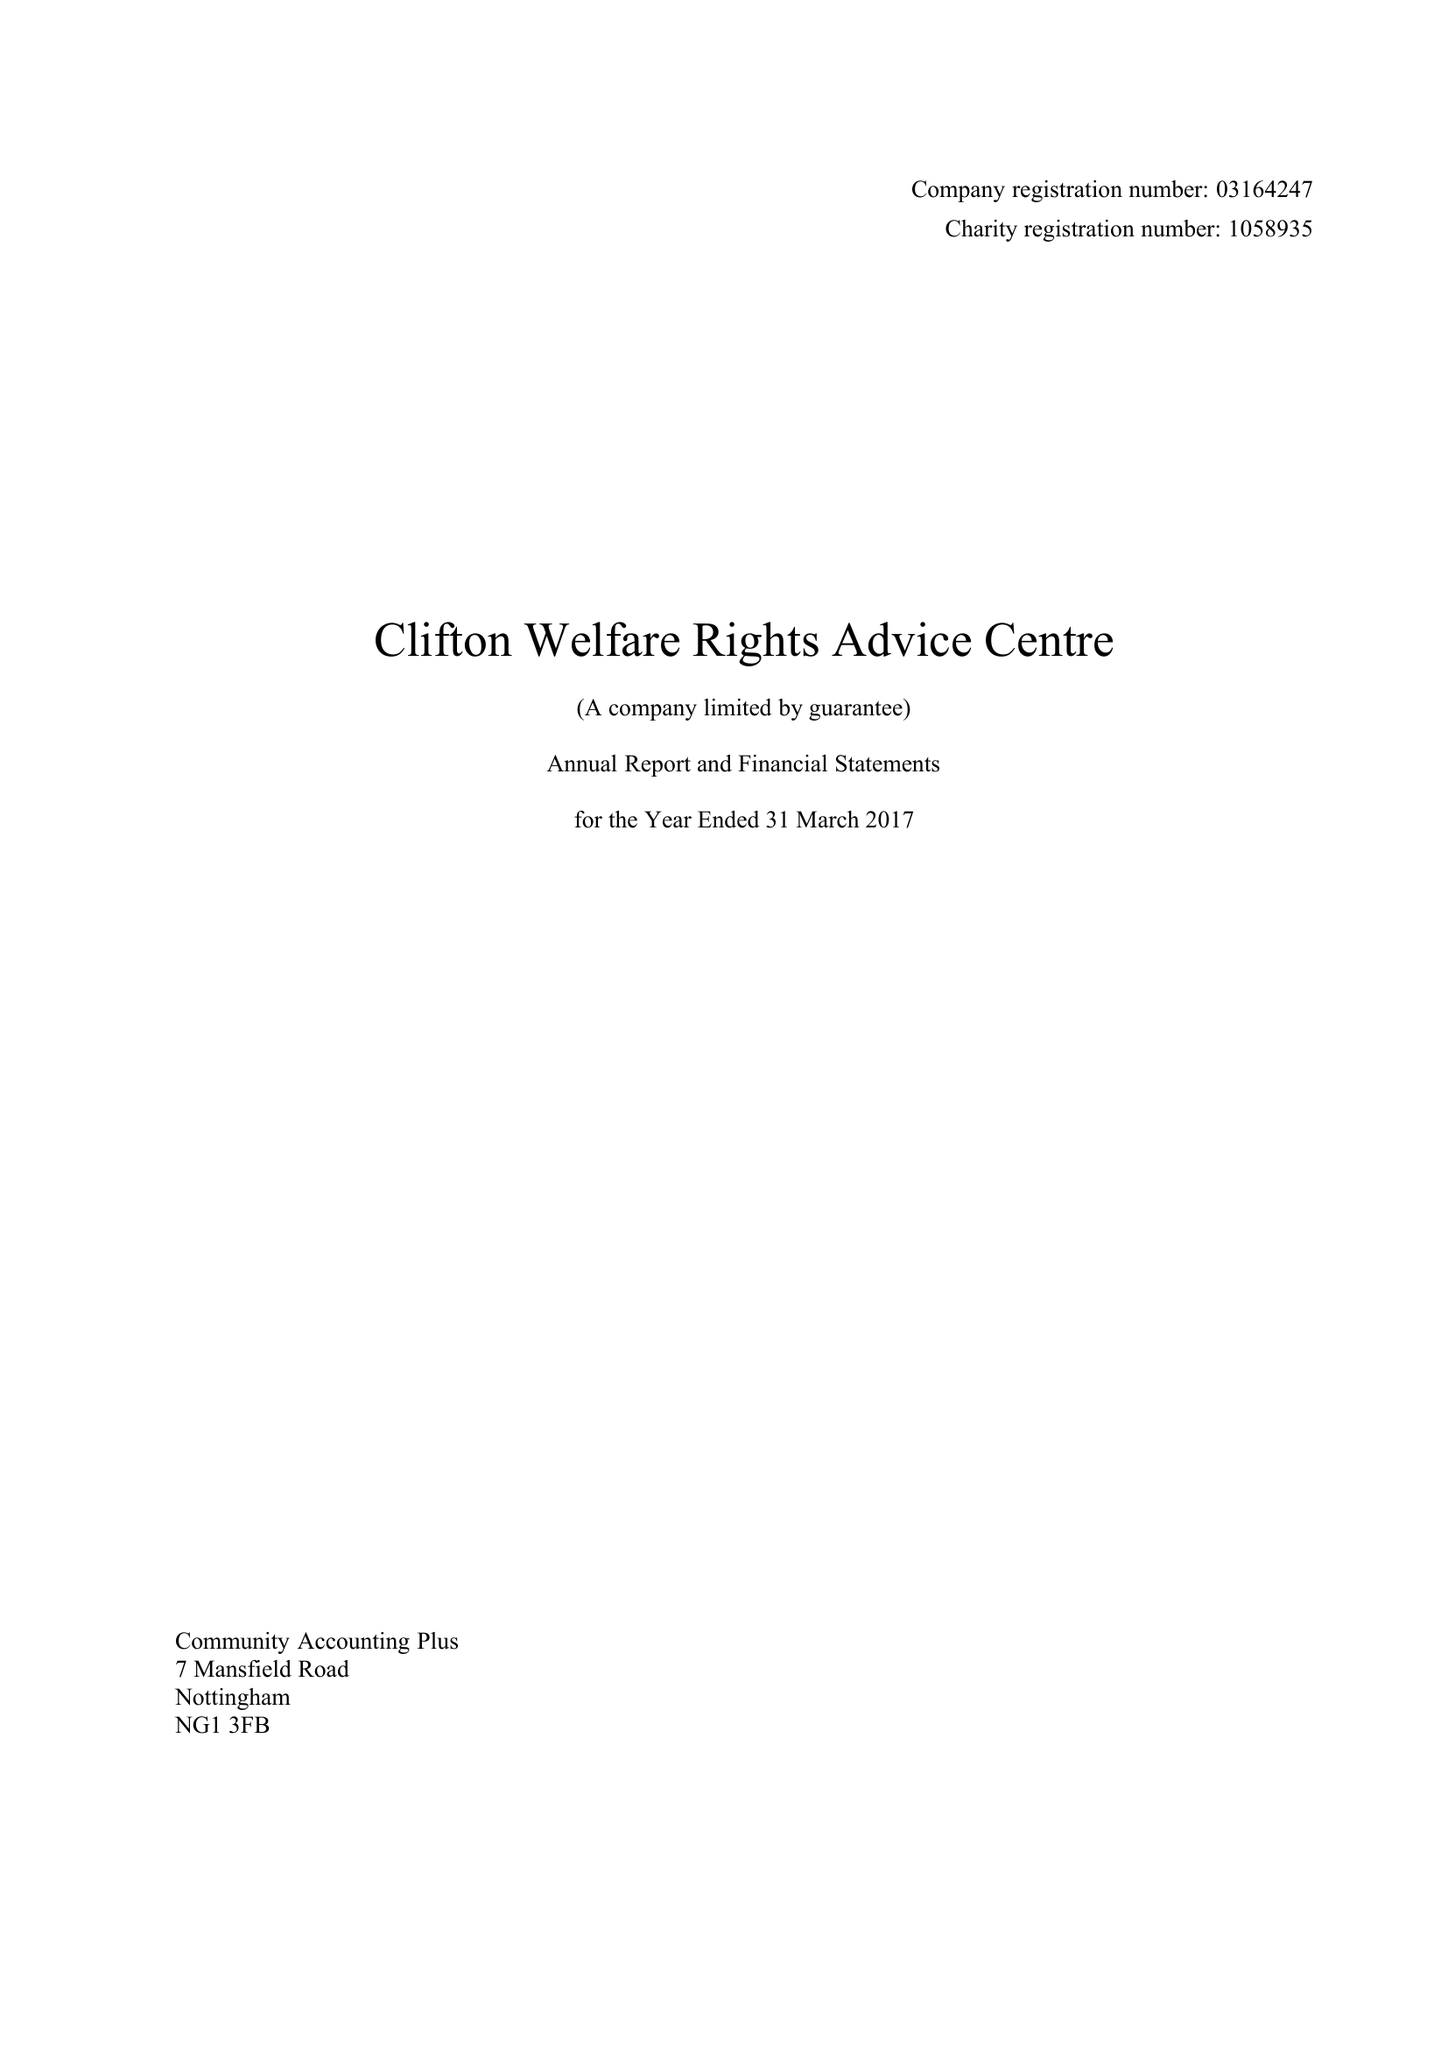What is the value for the report_date?
Answer the question using a single word or phrase. 2017-03-31 